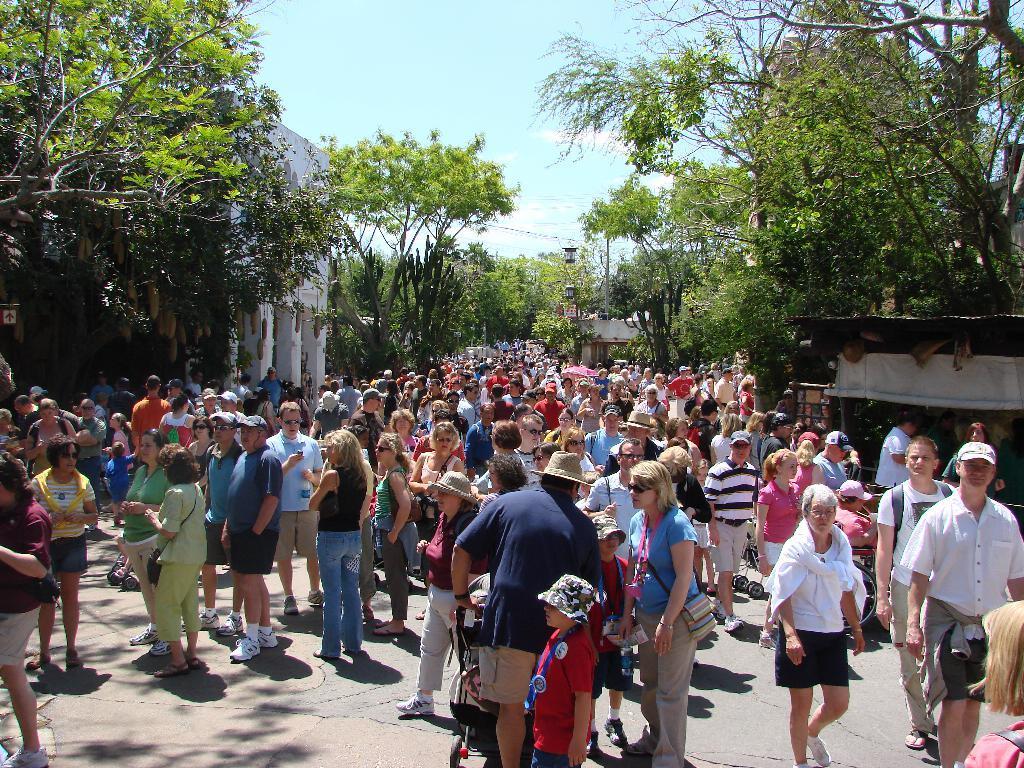Please provide a concise description of this image. In the picture we can see many people are standing and talking to each other and behind them, we can see the trees and the sky with clouds. 